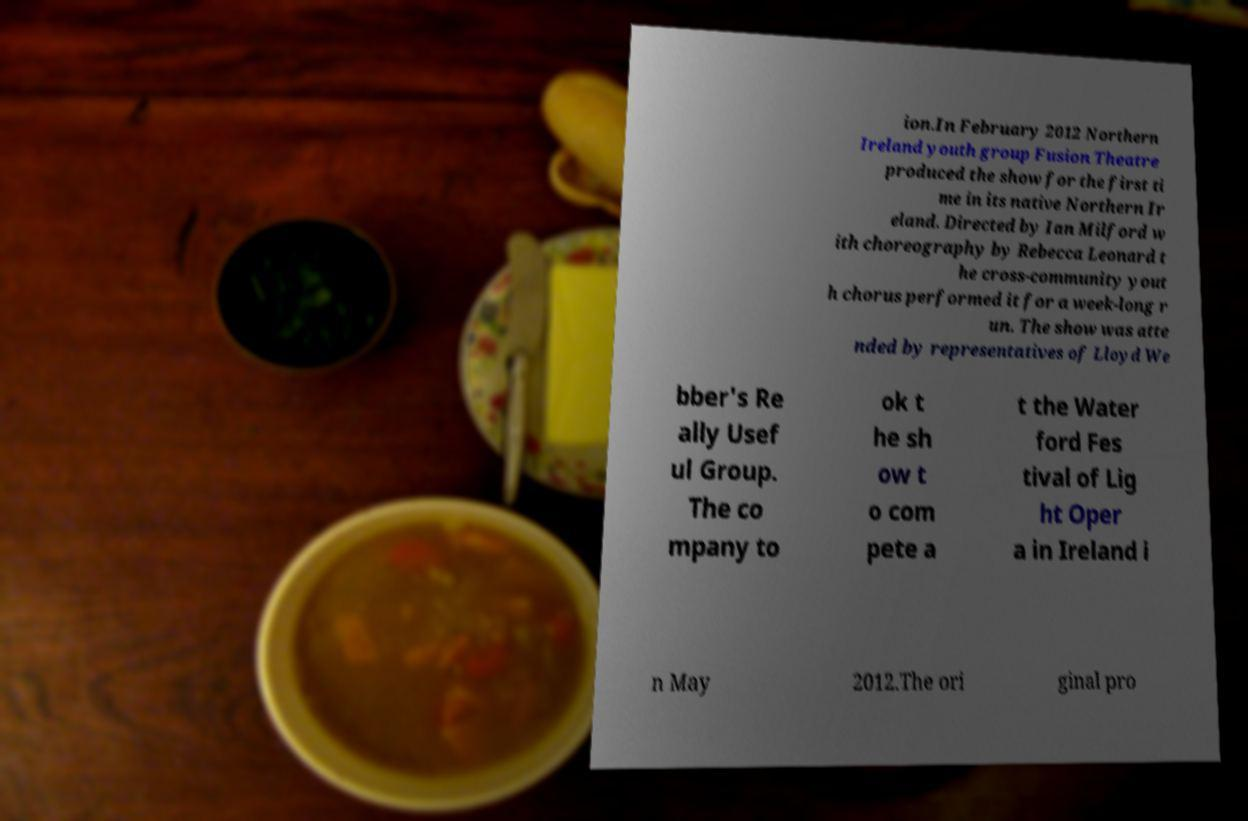What messages or text are displayed in this image? I need them in a readable, typed format. ion.In February 2012 Northern Ireland youth group Fusion Theatre produced the show for the first ti me in its native Northern Ir eland. Directed by Ian Milford w ith choreography by Rebecca Leonard t he cross-community yout h chorus performed it for a week-long r un. The show was atte nded by representatives of Lloyd We bber's Re ally Usef ul Group. The co mpany to ok t he sh ow t o com pete a t the Water ford Fes tival of Lig ht Oper a in Ireland i n May 2012.The ori ginal pro 